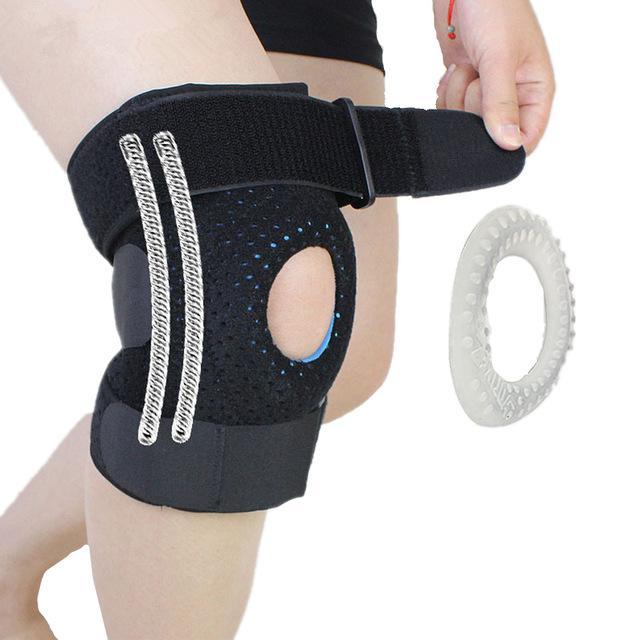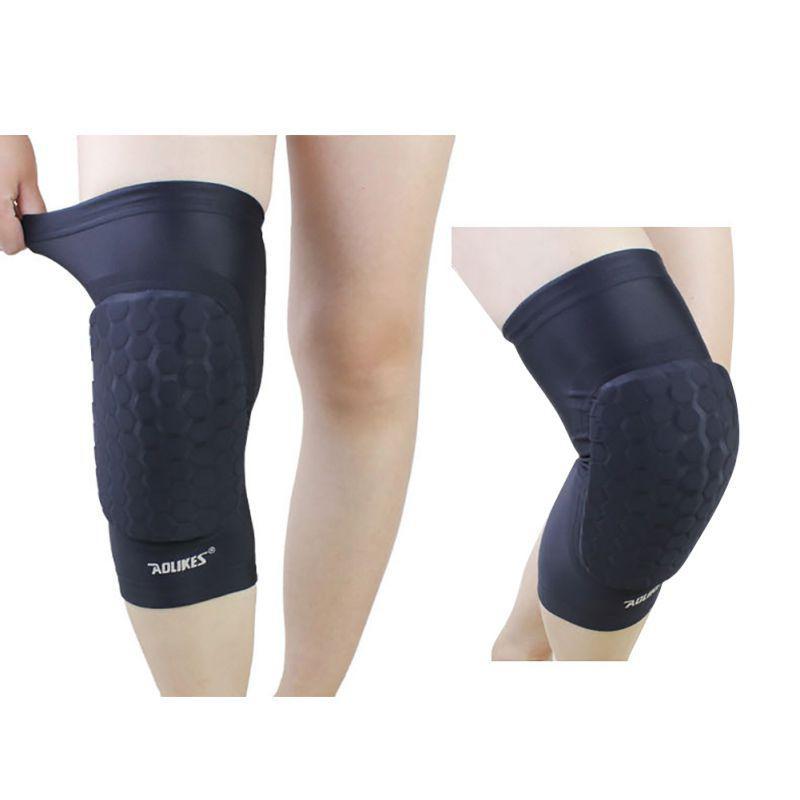The first image is the image on the left, the second image is the image on the right. For the images displayed, is the sentence "The right image contains at least one pair of legs." factually correct? Answer yes or no. Yes. 